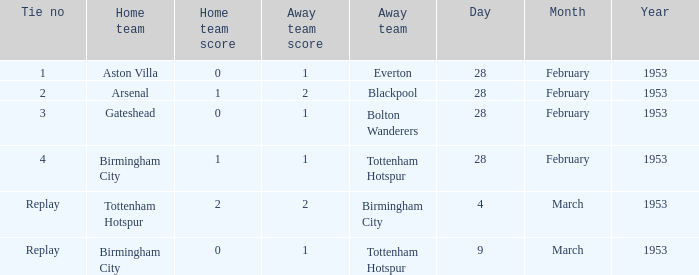Which tie from march 9, 1953, had a 0-1 score? Replay. 